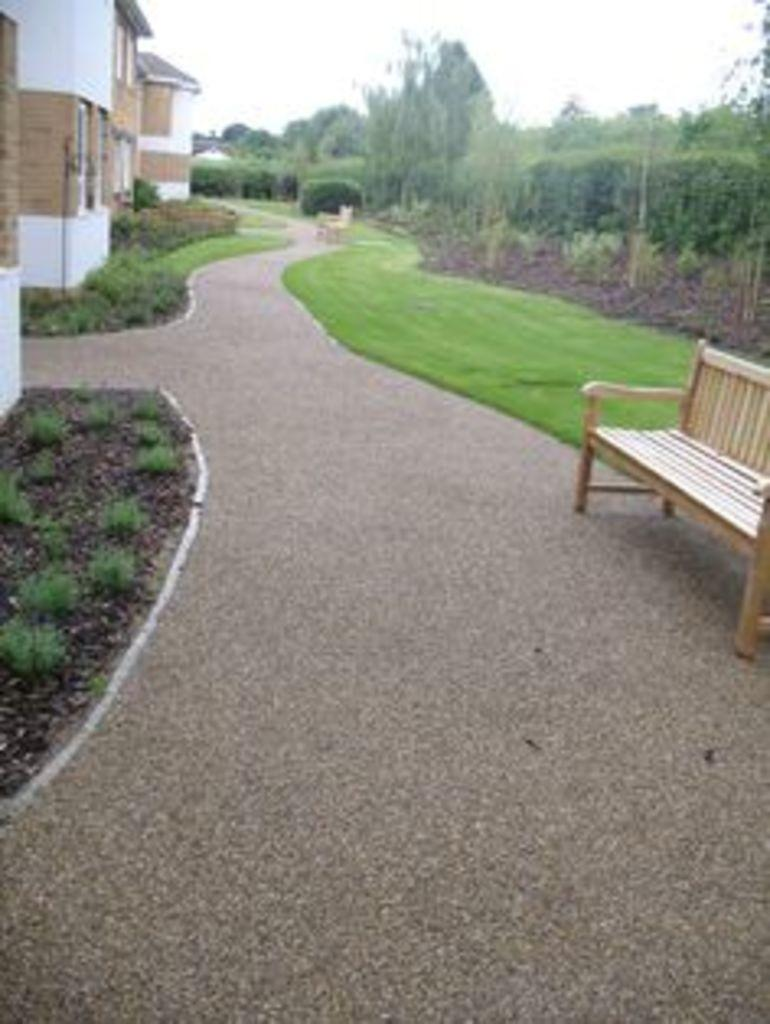What type of seating is visible in the image? There is a bench in the image. What type of vegetation is present in the image? There is grass in the image. What can be seen on the right side of the image? There are trees on the right side of the image. What is in the center of the image? There is a road in the center of the image. What type of structures are on the left side of the image? There are buildings on the left side of the image. What is visible at the top of the image? The sky is visible at the top of the image. Where is the quartz located in the image? There is no quartz present in the image. Can you tell me how many sisters are visible in the image? There are no people, including sisters, present in the image. 